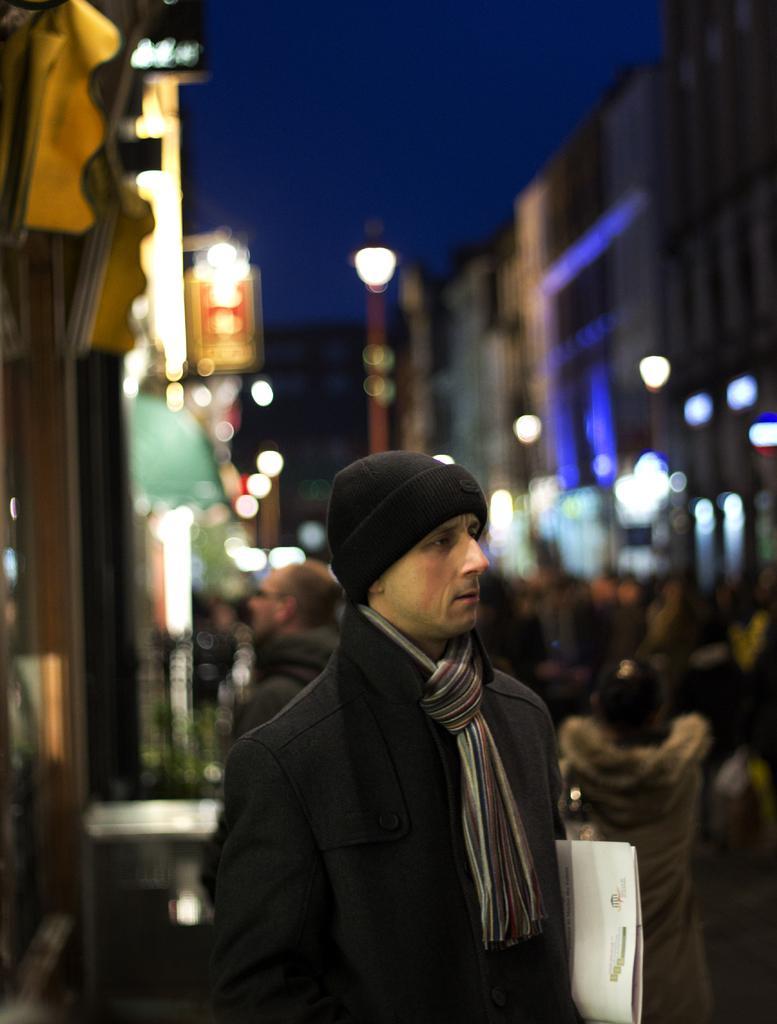How would you summarize this image in a sentence or two? In the image there is a man in the middle with grey suit,scarf and black cap holding a file, this is clicked on a street, in the back there are buildings on either side with many people walking in the middle of the road, this is clicked at night time and above its sky. 